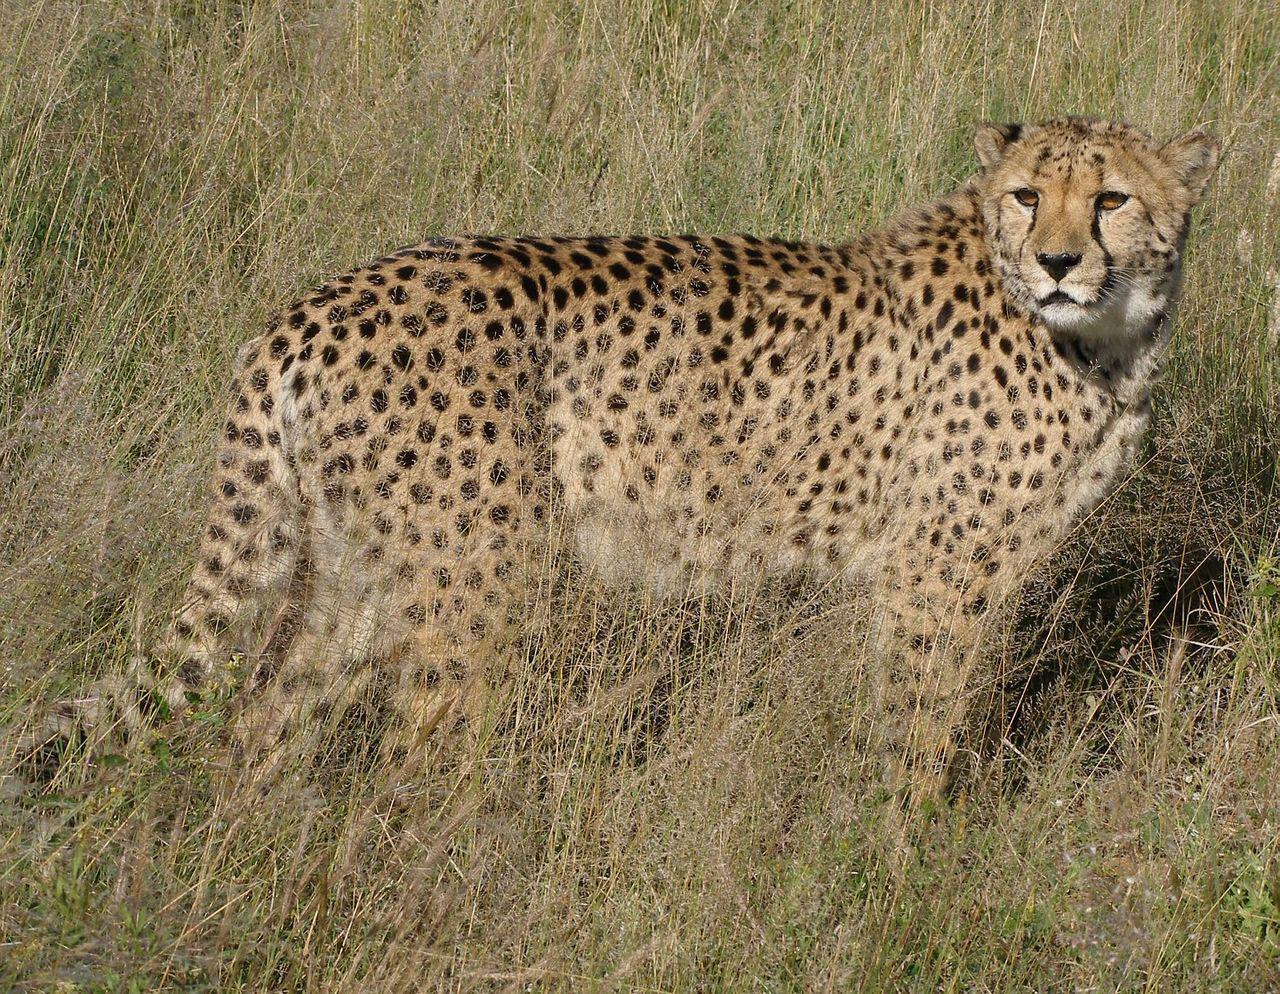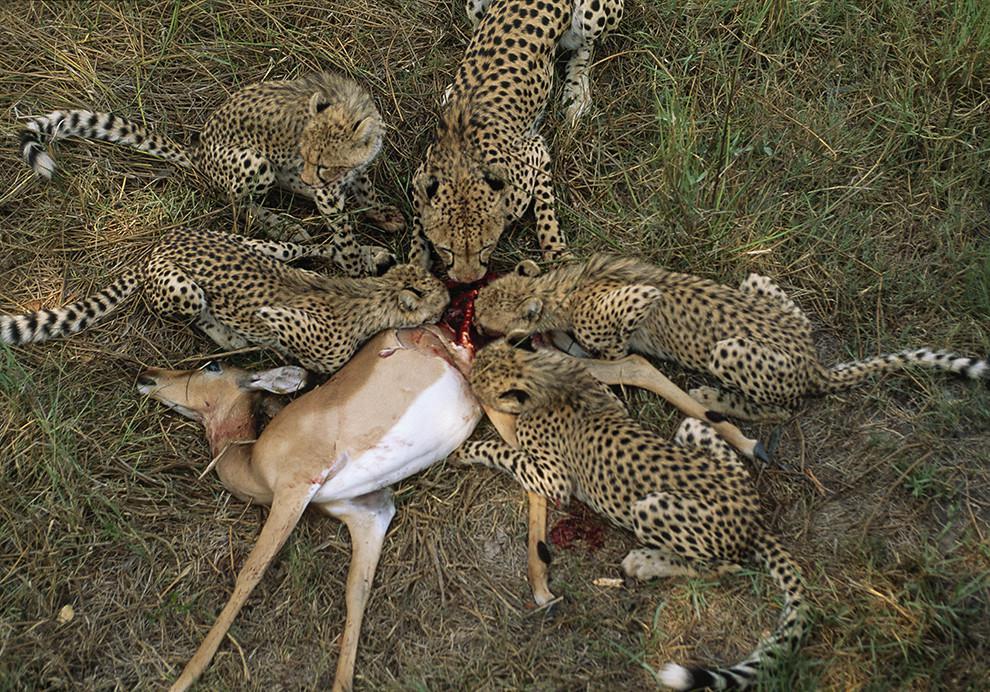The first image is the image on the left, the second image is the image on the right. For the images displayed, is the sentence "A horned animal is being bitten on the ground by at least one cheetah in the image on the right." factually correct? Answer yes or no. Yes. The first image is the image on the left, the second image is the image on the right. Assess this claim about the two images: "The right image shows one cheetah capturing a gazelle-type animal, and the left image shows a cheetah crouched behind entrails.". Correct or not? Answer yes or no. No. 